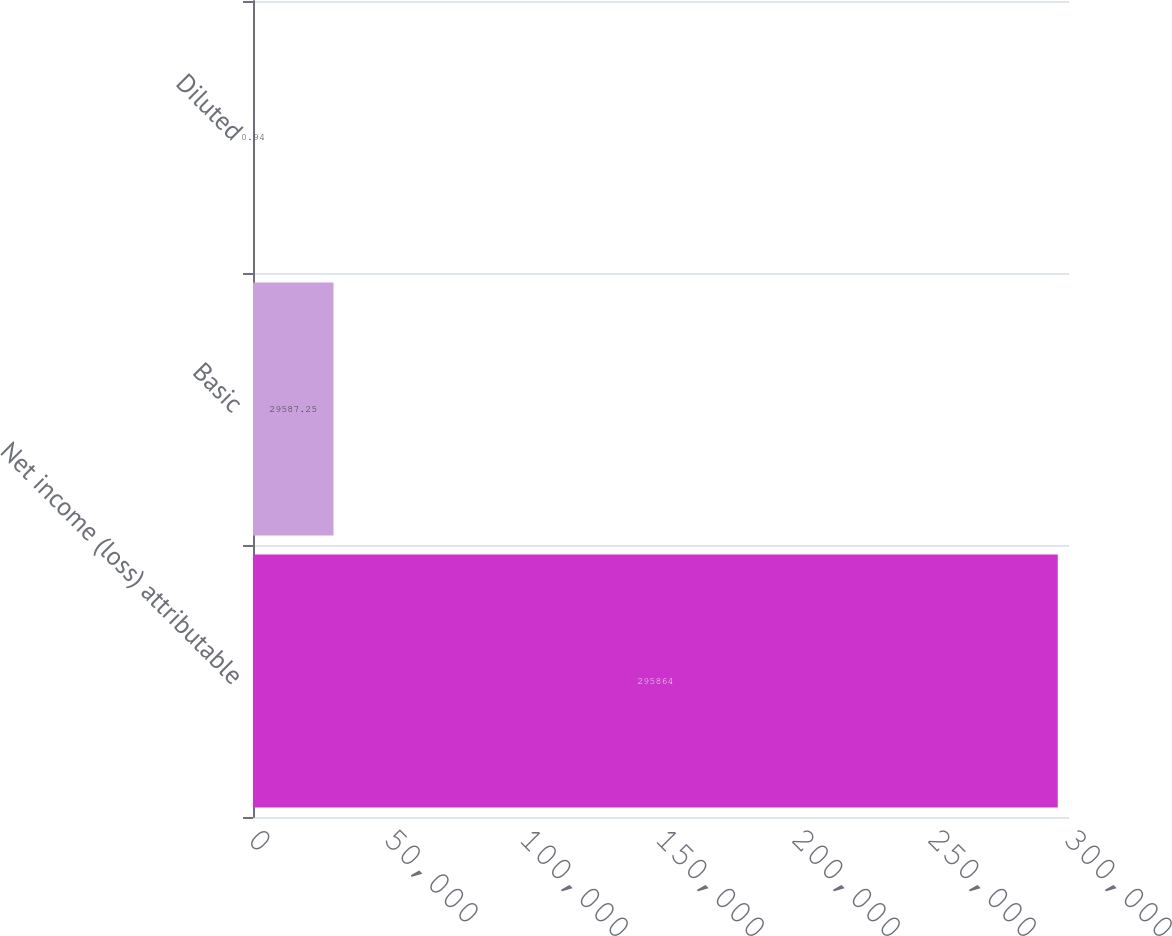<chart> <loc_0><loc_0><loc_500><loc_500><bar_chart><fcel>Net income (loss) attributable<fcel>Basic<fcel>Diluted<nl><fcel>295864<fcel>29587.2<fcel>0.94<nl></chart> 